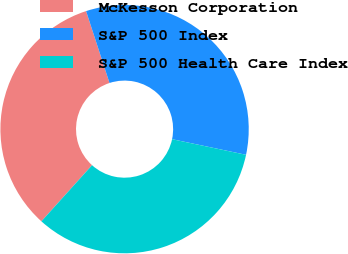Convert chart to OTSL. <chart><loc_0><loc_0><loc_500><loc_500><pie_chart><fcel>McKesson Corporation<fcel>S&P 500 Index<fcel>S&P 500 Health Care Index<nl><fcel>33.3%<fcel>33.33%<fcel>33.37%<nl></chart> 